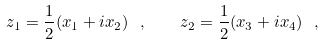<formula> <loc_0><loc_0><loc_500><loc_500>z _ { 1 } = \frac { 1 } { 2 } ( x _ { 1 } + i x _ { 2 } ) \ , \quad z _ { 2 } = \frac { 1 } { 2 } ( x _ { 3 } + i x _ { 4 } ) \ ,</formula> 